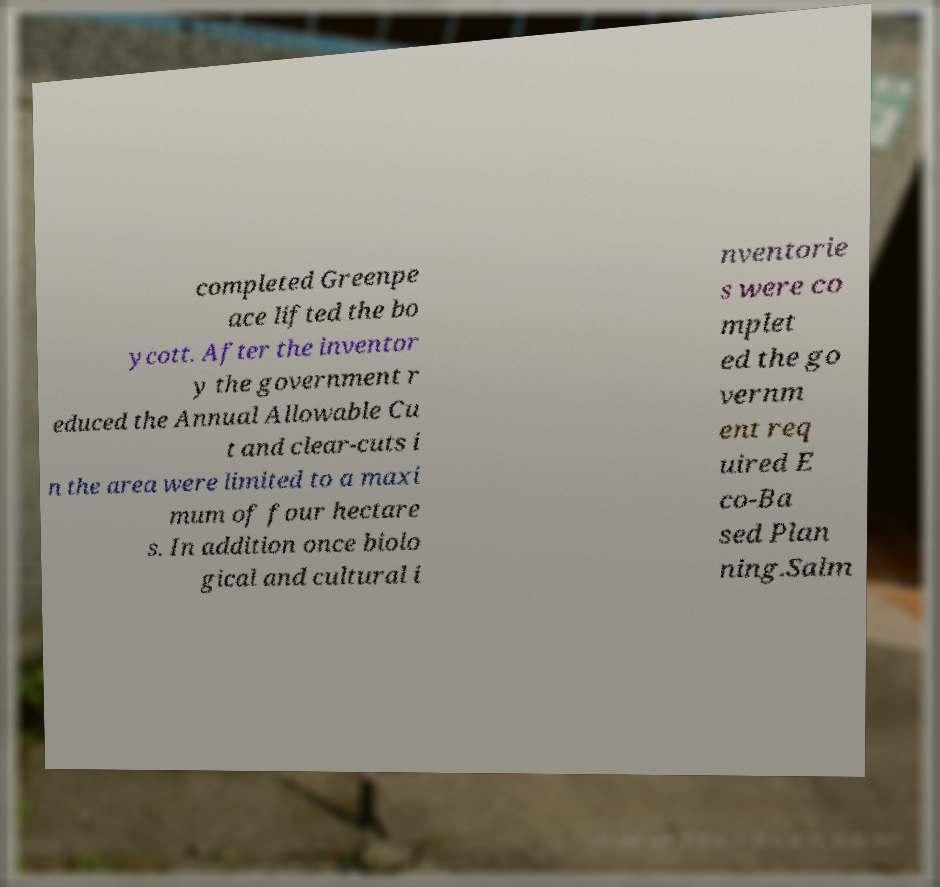Please identify and transcribe the text found in this image. completed Greenpe ace lifted the bo ycott. After the inventor y the government r educed the Annual Allowable Cu t and clear-cuts i n the area were limited to a maxi mum of four hectare s. In addition once biolo gical and cultural i nventorie s were co mplet ed the go vernm ent req uired E co-Ba sed Plan ning.Salm 